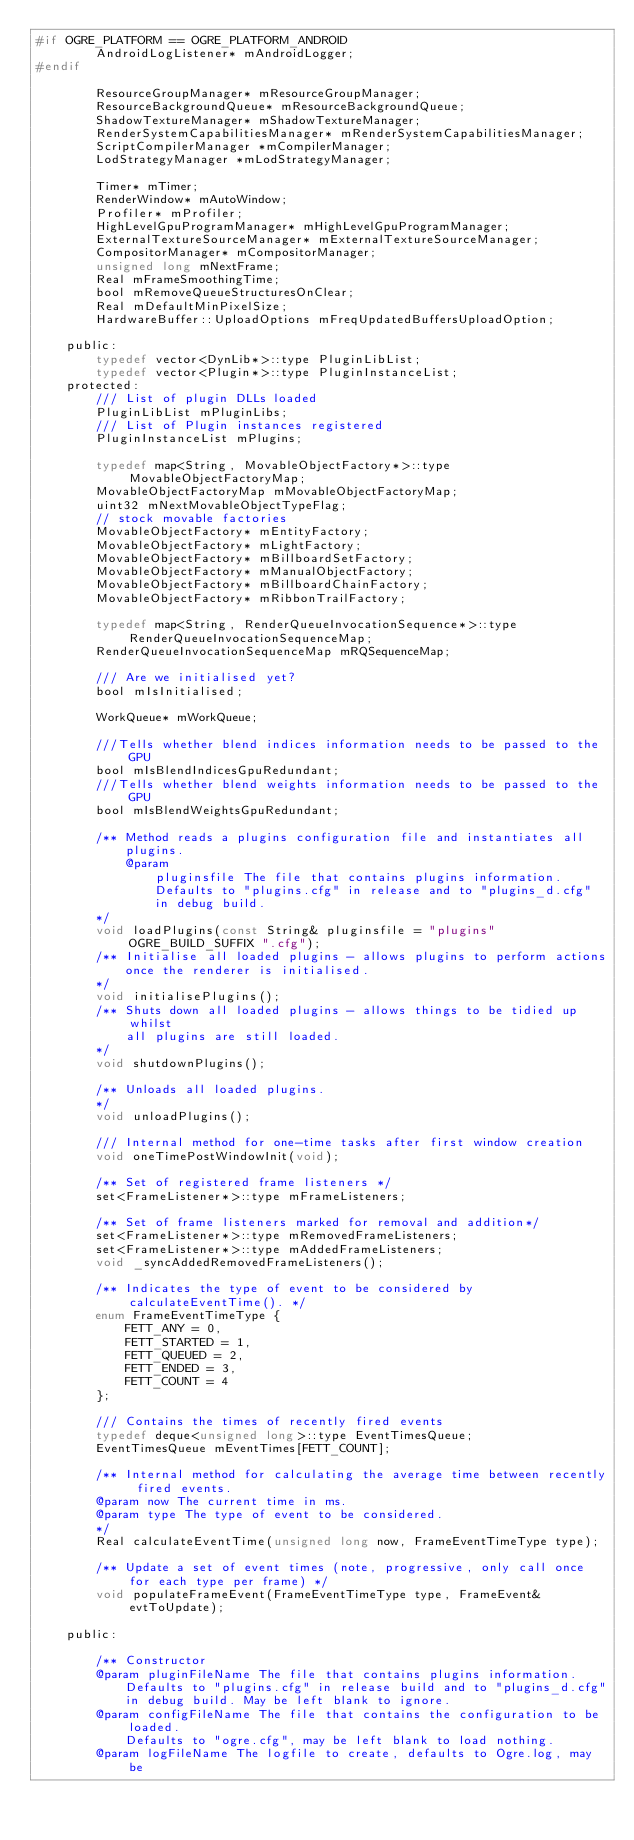Convert code to text. <code><loc_0><loc_0><loc_500><loc_500><_C_>#if OGRE_PLATFORM == OGRE_PLATFORM_ANDROID
        AndroidLogListener* mAndroidLogger;
#endif
        
        ResourceGroupManager* mResourceGroupManager;
        ResourceBackgroundQueue* mResourceBackgroundQueue;
        ShadowTextureManager* mShadowTextureManager;
        RenderSystemCapabilitiesManager* mRenderSystemCapabilitiesManager;
        ScriptCompilerManager *mCompilerManager;
        LodStrategyManager *mLodStrategyManager;

        Timer* mTimer;
        RenderWindow* mAutoWindow;
        Profiler* mProfiler;
        HighLevelGpuProgramManager* mHighLevelGpuProgramManager;
        ExternalTextureSourceManager* mExternalTextureSourceManager;
        CompositorManager* mCompositorManager;      
        unsigned long mNextFrame;
        Real mFrameSmoothingTime;
        bool mRemoveQueueStructuresOnClear;
        Real mDefaultMinPixelSize;
        HardwareBuffer::UploadOptions mFreqUpdatedBuffersUploadOption;

    public:
        typedef vector<DynLib*>::type PluginLibList;
        typedef vector<Plugin*>::type PluginInstanceList;
    protected:
        /// List of plugin DLLs loaded
        PluginLibList mPluginLibs;
        /// List of Plugin instances registered
        PluginInstanceList mPlugins;

        typedef map<String, MovableObjectFactory*>::type MovableObjectFactoryMap;
        MovableObjectFactoryMap mMovableObjectFactoryMap;
        uint32 mNextMovableObjectTypeFlag;
        // stock movable factories
        MovableObjectFactory* mEntityFactory;
        MovableObjectFactory* mLightFactory;
        MovableObjectFactory* mBillboardSetFactory;
        MovableObjectFactory* mManualObjectFactory;
        MovableObjectFactory* mBillboardChainFactory;
        MovableObjectFactory* mRibbonTrailFactory;

        typedef map<String, RenderQueueInvocationSequence*>::type RenderQueueInvocationSequenceMap;
        RenderQueueInvocationSequenceMap mRQSequenceMap;

        /// Are we initialised yet?
        bool mIsInitialised;

        WorkQueue* mWorkQueue;

        ///Tells whether blend indices information needs to be passed to the GPU
        bool mIsBlendIndicesGpuRedundant;
        ///Tells whether blend weights information needs to be passed to the GPU
        bool mIsBlendWeightsGpuRedundant;

        /** Method reads a plugins configuration file and instantiates all
            plugins.
            @param
                pluginsfile The file that contains plugins information.
                Defaults to "plugins.cfg" in release and to "plugins_d.cfg"
                in debug build.
        */
        void loadPlugins(const String& pluginsfile = "plugins" OGRE_BUILD_SUFFIX ".cfg");
        /** Initialise all loaded plugins - allows plugins to perform actions
            once the renderer is initialised.
        */
        void initialisePlugins();
        /** Shuts down all loaded plugins - allows things to be tidied up whilst
            all plugins are still loaded.
        */
        void shutdownPlugins();

        /** Unloads all loaded plugins.
        */
        void unloadPlugins();

        /// Internal method for one-time tasks after first window creation
        void oneTimePostWindowInit(void);

        /** Set of registered frame listeners */
        set<FrameListener*>::type mFrameListeners;

        /** Set of frame listeners marked for removal and addition*/
        set<FrameListener*>::type mRemovedFrameListeners;
        set<FrameListener*>::type mAddedFrameListeners;
        void _syncAddedRemovedFrameListeners();

        /** Indicates the type of event to be considered by calculateEventTime(). */
        enum FrameEventTimeType {
            FETT_ANY = 0, 
            FETT_STARTED = 1, 
            FETT_QUEUED = 2, 
            FETT_ENDED = 3, 
            FETT_COUNT = 4
        };

        /// Contains the times of recently fired events
        typedef deque<unsigned long>::type EventTimesQueue;
        EventTimesQueue mEventTimes[FETT_COUNT];

        /** Internal method for calculating the average time between recently fired events.
        @param now The current time in ms.
        @param type The type of event to be considered.
        */
        Real calculateEventTime(unsigned long now, FrameEventTimeType type);

        /** Update a set of event times (note, progressive, only call once for each type per frame) */
        void populateFrameEvent(FrameEventTimeType type, FrameEvent& evtToUpdate);

    public:

        /** Constructor
        @param pluginFileName The file that contains plugins information.
            Defaults to "plugins.cfg" in release build and to "plugins_d.cfg"
            in debug build. May be left blank to ignore.
        @param configFileName The file that contains the configuration to be loaded.
            Defaults to "ogre.cfg", may be left blank to load nothing.
        @param logFileName The logfile to create, defaults to Ogre.log, may be </code> 